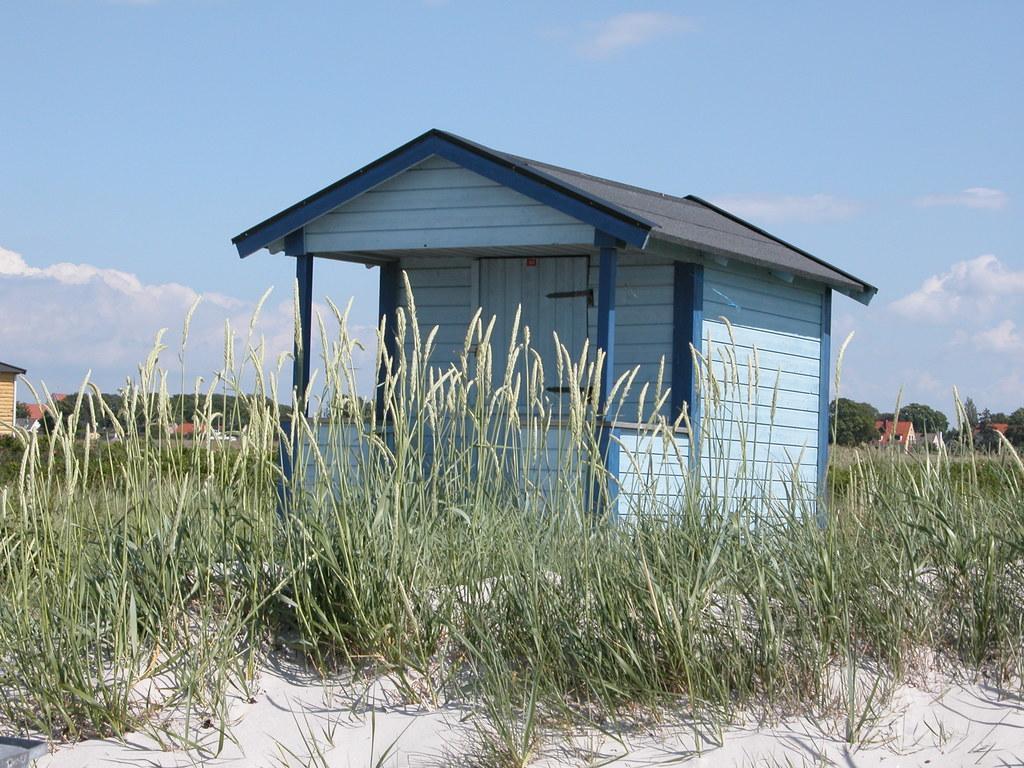Can you describe this image briefly? In this picture there is a wooden hut. Beside that I can see the grass. At the bottom I can see the sand. In the background I can see the buildings, trees, plants and pole. At the top I can see the sky and clouds. 